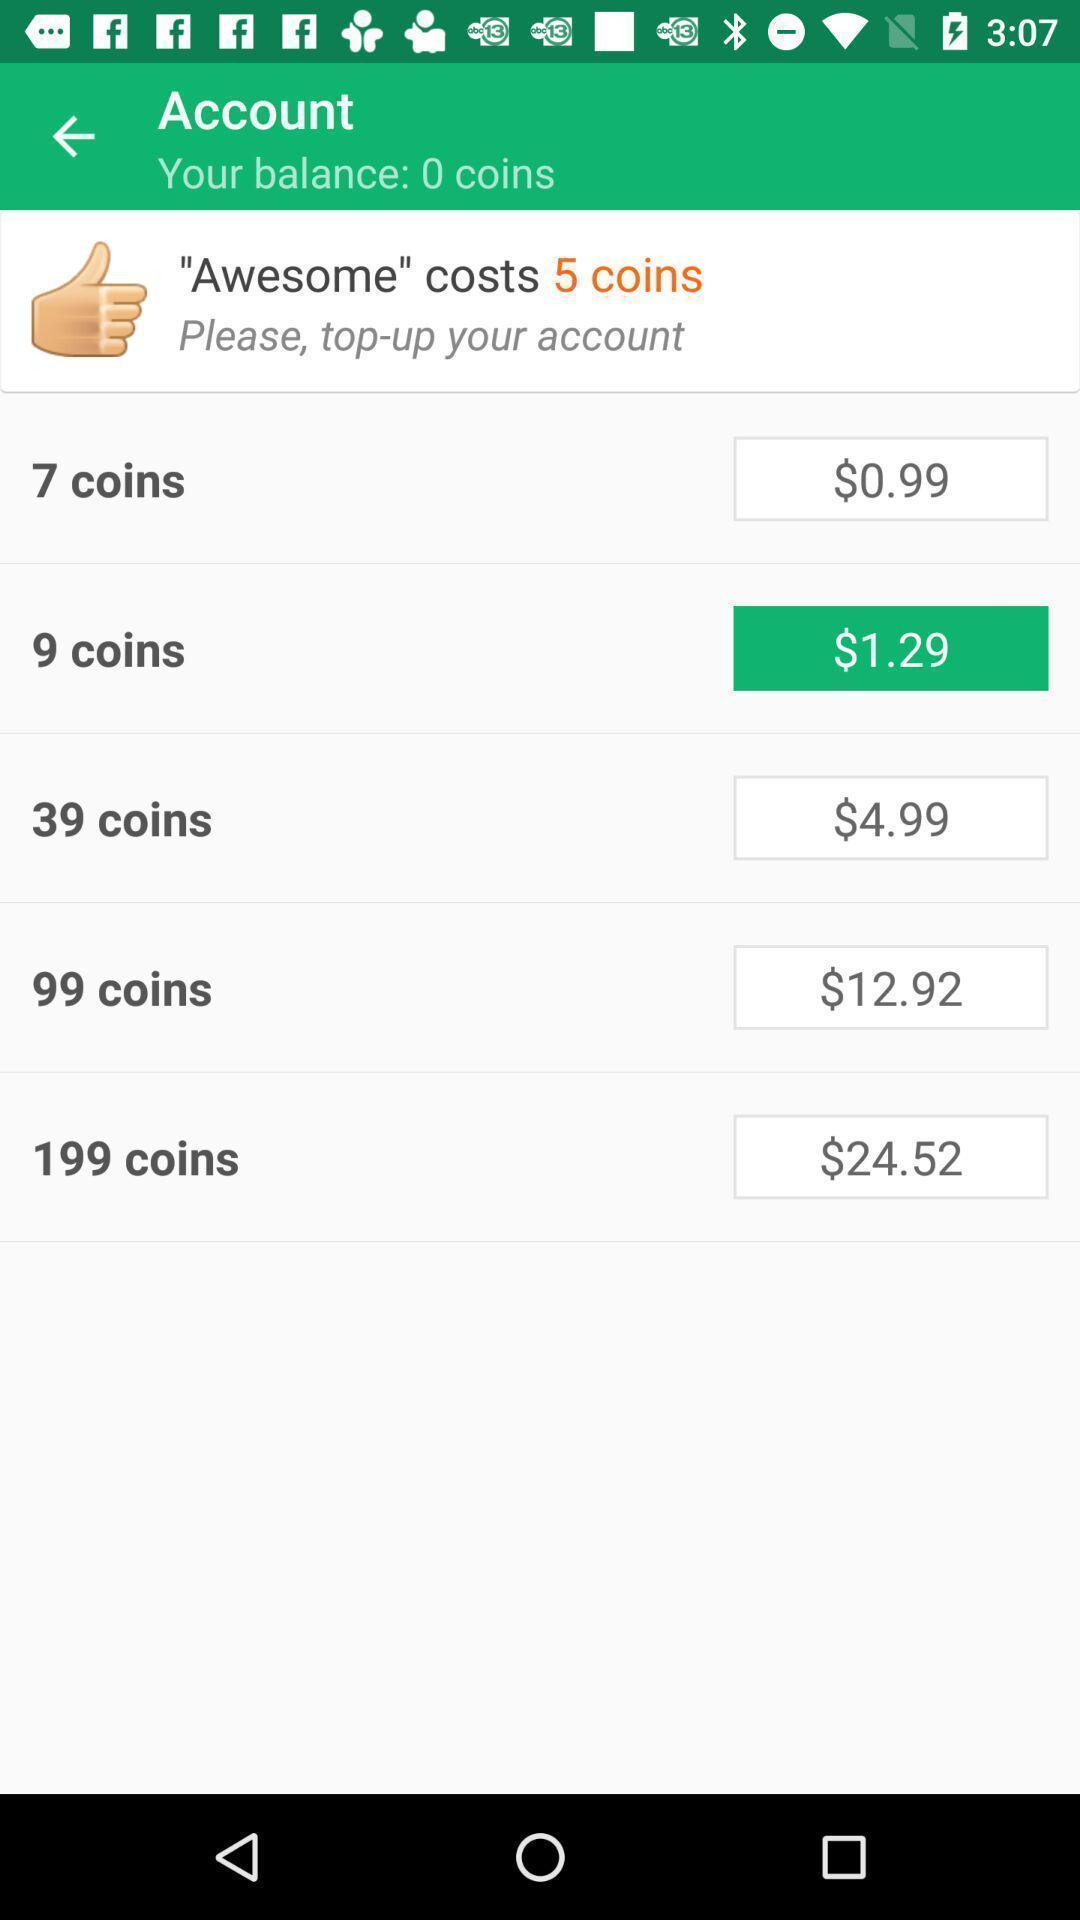Describe the visual elements of this screenshot. Page displaying with list of coins and price in application. 